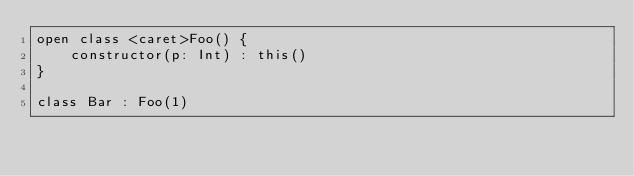Convert code to text. <code><loc_0><loc_0><loc_500><loc_500><_Kotlin_>open class <caret>Foo() {
    constructor(p: Int) : this()
}

class Bar : Foo(1)</code> 